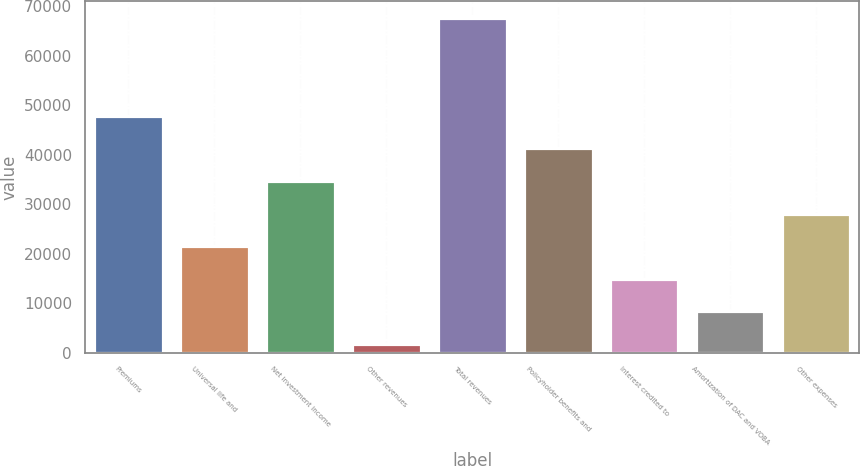<chart> <loc_0><loc_0><loc_500><loc_500><bar_chart><fcel>Premiums<fcel>Universal life and<fcel>Net investment income<fcel>Other revenues<fcel>Total revenues<fcel>Policyholder benefits and<fcel>Interest credited to<fcel>Amortization of DAC and VOBA<fcel>Other expenses<nl><fcel>47853.8<fcel>21512.2<fcel>34683<fcel>1756<fcel>67610<fcel>41268.4<fcel>14926.8<fcel>8341.4<fcel>28097.6<nl></chart> 